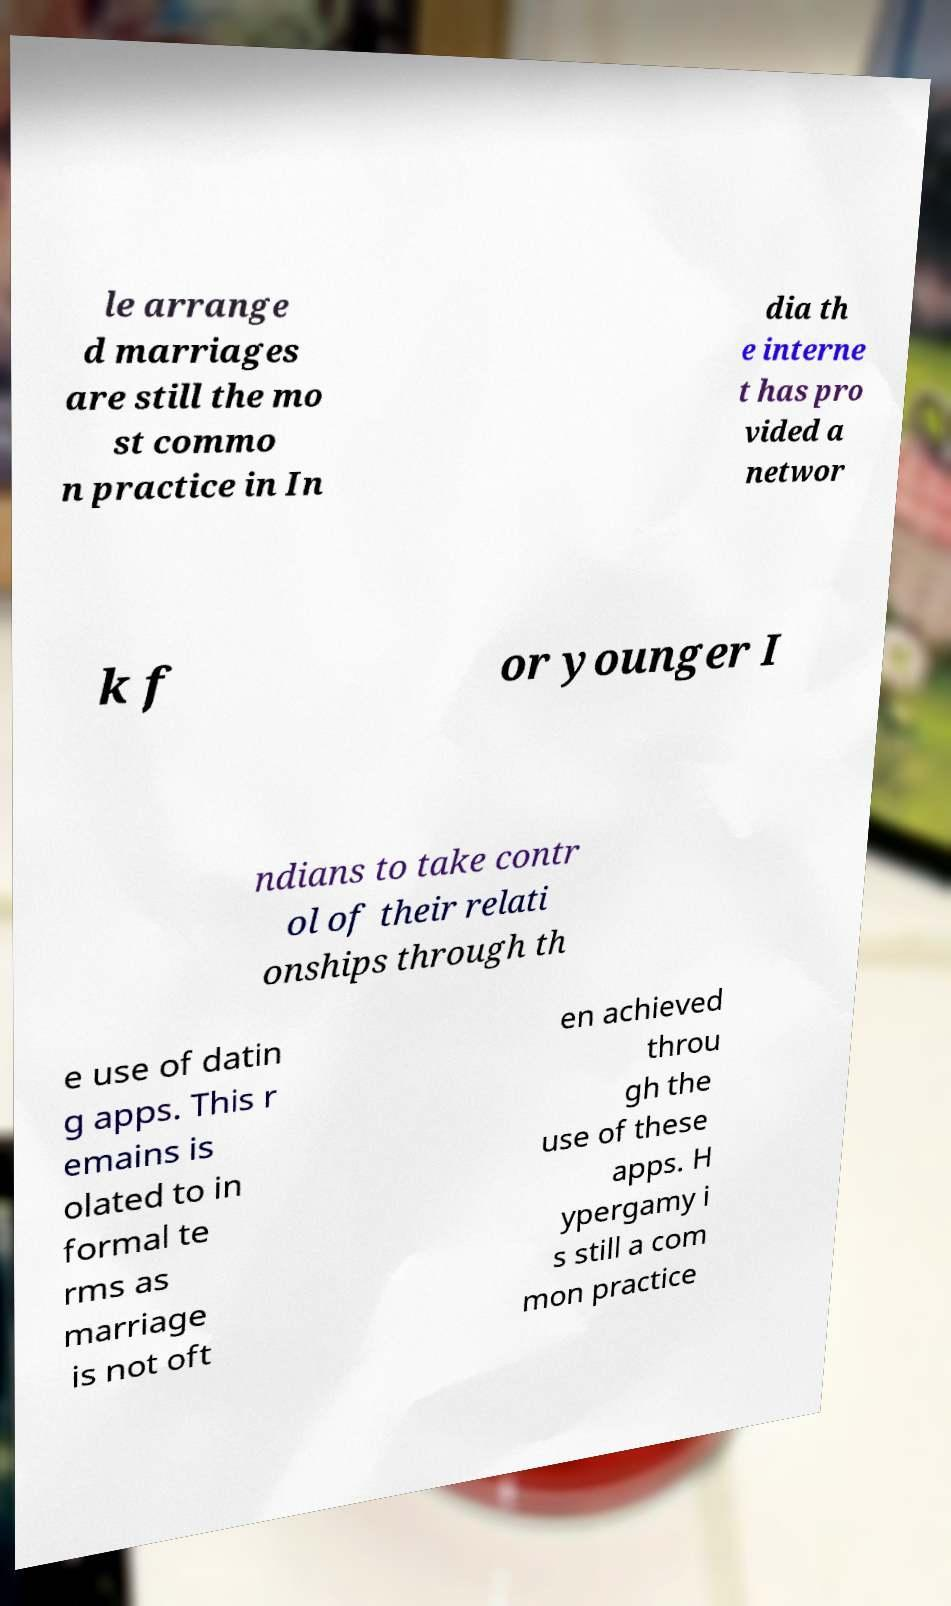Can you read and provide the text displayed in the image?This photo seems to have some interesting text. Can you extract and type it out for me? le arrange d marriages are still the mo st commo n practice in In dia th e interne t has pro vided a networ k f or younger I ndians to take contr ol of their relati onships through th e use of datin g apps. This r emains is olated to in formal te rms as marriage is not oft en achieved throu gh the use of these apps. H ypergamy i s still a com mon practice 